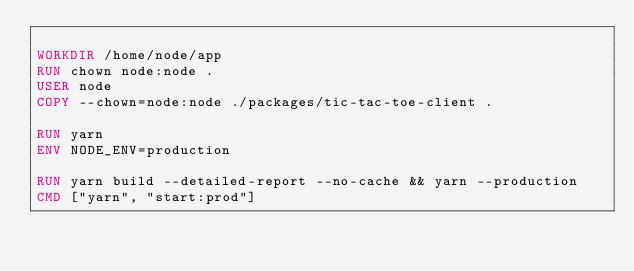<code> <loc_0><loc_0><loc_500><loc_500><_Dockerfile_>
WORKDIR /home/node/app
RUN chown node:node .
USER node
COPY --chown=node:node ./packages/tic-tac-toe-client .

RUN yarn
ENV NODE_ENV=production

RUN yarn build --detailed-report --no-cache && yarn --production
CMD ["yarn", "start:prod"]
</code> 